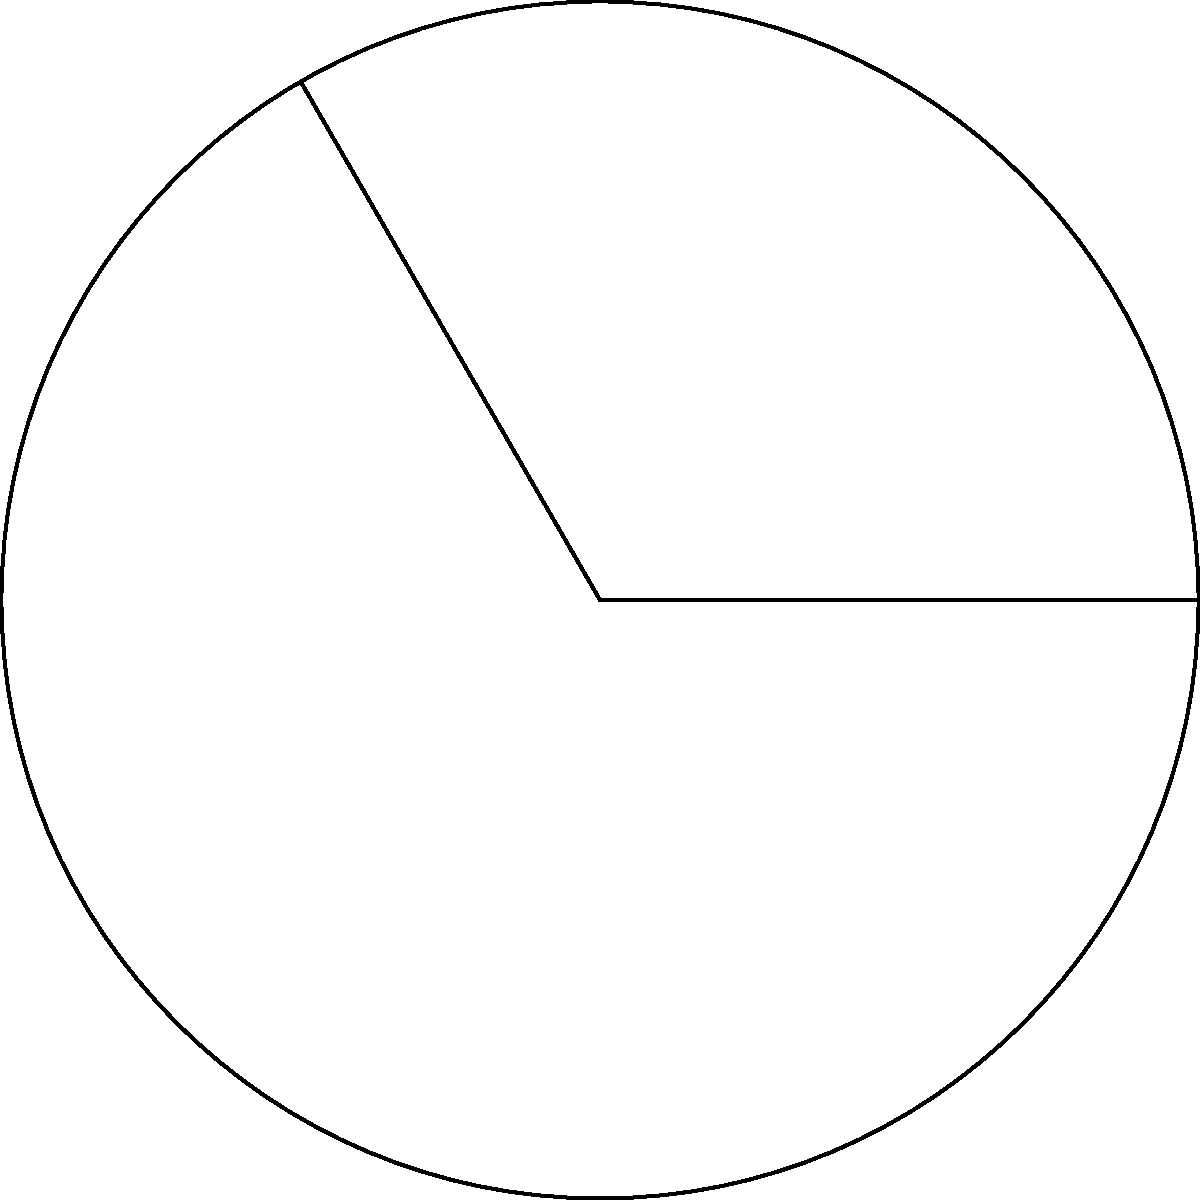In eye surgery, understanding the curvature of the retina is crucial. Consider a circular model of the eye with a radius of 12 mm. If a surgical procedure needs to cover an arc length of 25.13 mm along the retina's curvature, what is the central angle (in degrees) that this arc subtends? To solve this problem, we'll use the formula for arc length and work backwards to find the central angle. Let's approach this step-by-step:

1) The formula for arc length is:
   $s = r\theta$
   where $s$ is the arc length, $r$ is the radius, and $\theta$ is the central angle in radians.

2) We're given:
   $r = 12$ mm
   $s = 25.13$ mm

3) Substituting these into the formula:
   $25.13 = 12\theta$

4) Solving for $\theta$:
   $\theta = \frac{25.13}{12} = 2.09416667$ radians

5) We need to convert this to degrees. The conversion formula is:
   $\text{degrees} = \text{radians} \times \frac{180°}{\pi}$

6) Plugging in our value:
   $\text{degrees} = 2.09416667 \times \frac{180°}{\pi} = 120°$

Therefore, the central angle subtended by the arc is 120°.
Answer: 120° 